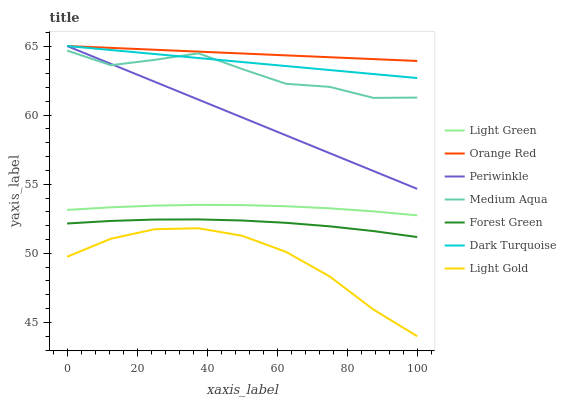Does Forest Green have the minimum area under the curve?
Answer yes or no. No. Does Forest Green have the maximum area under the curve?
Answer yes or no. No. Is Forest Green the smoothest?
Answer yes or no. No. Is Forest Green the roughest?
Answer yes or no. No. Does Forest Green have the lowest value?
Answer yes or no. No. Does Forest Green have the highest value?
Answer yes or no. No. Is Medium Aqua less than Orange Red?
Answer yes or no. Yes. Is Dark Turquoise greater than Light Gold?
Answer yes or no. Yes. Does Medium Aqua intersect Orange Red?
Answer yes or no. No. 